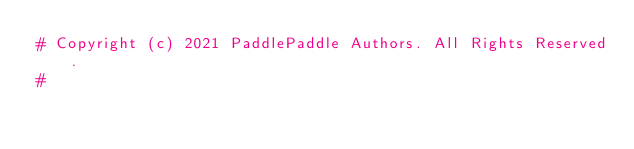Convert code to text. <code><loc_0><loc_0><loc_500><loc_500><_Python_># Copyright (c) 2021 PaddlePaddle Authors. All Rights Reserved.
#</code> 